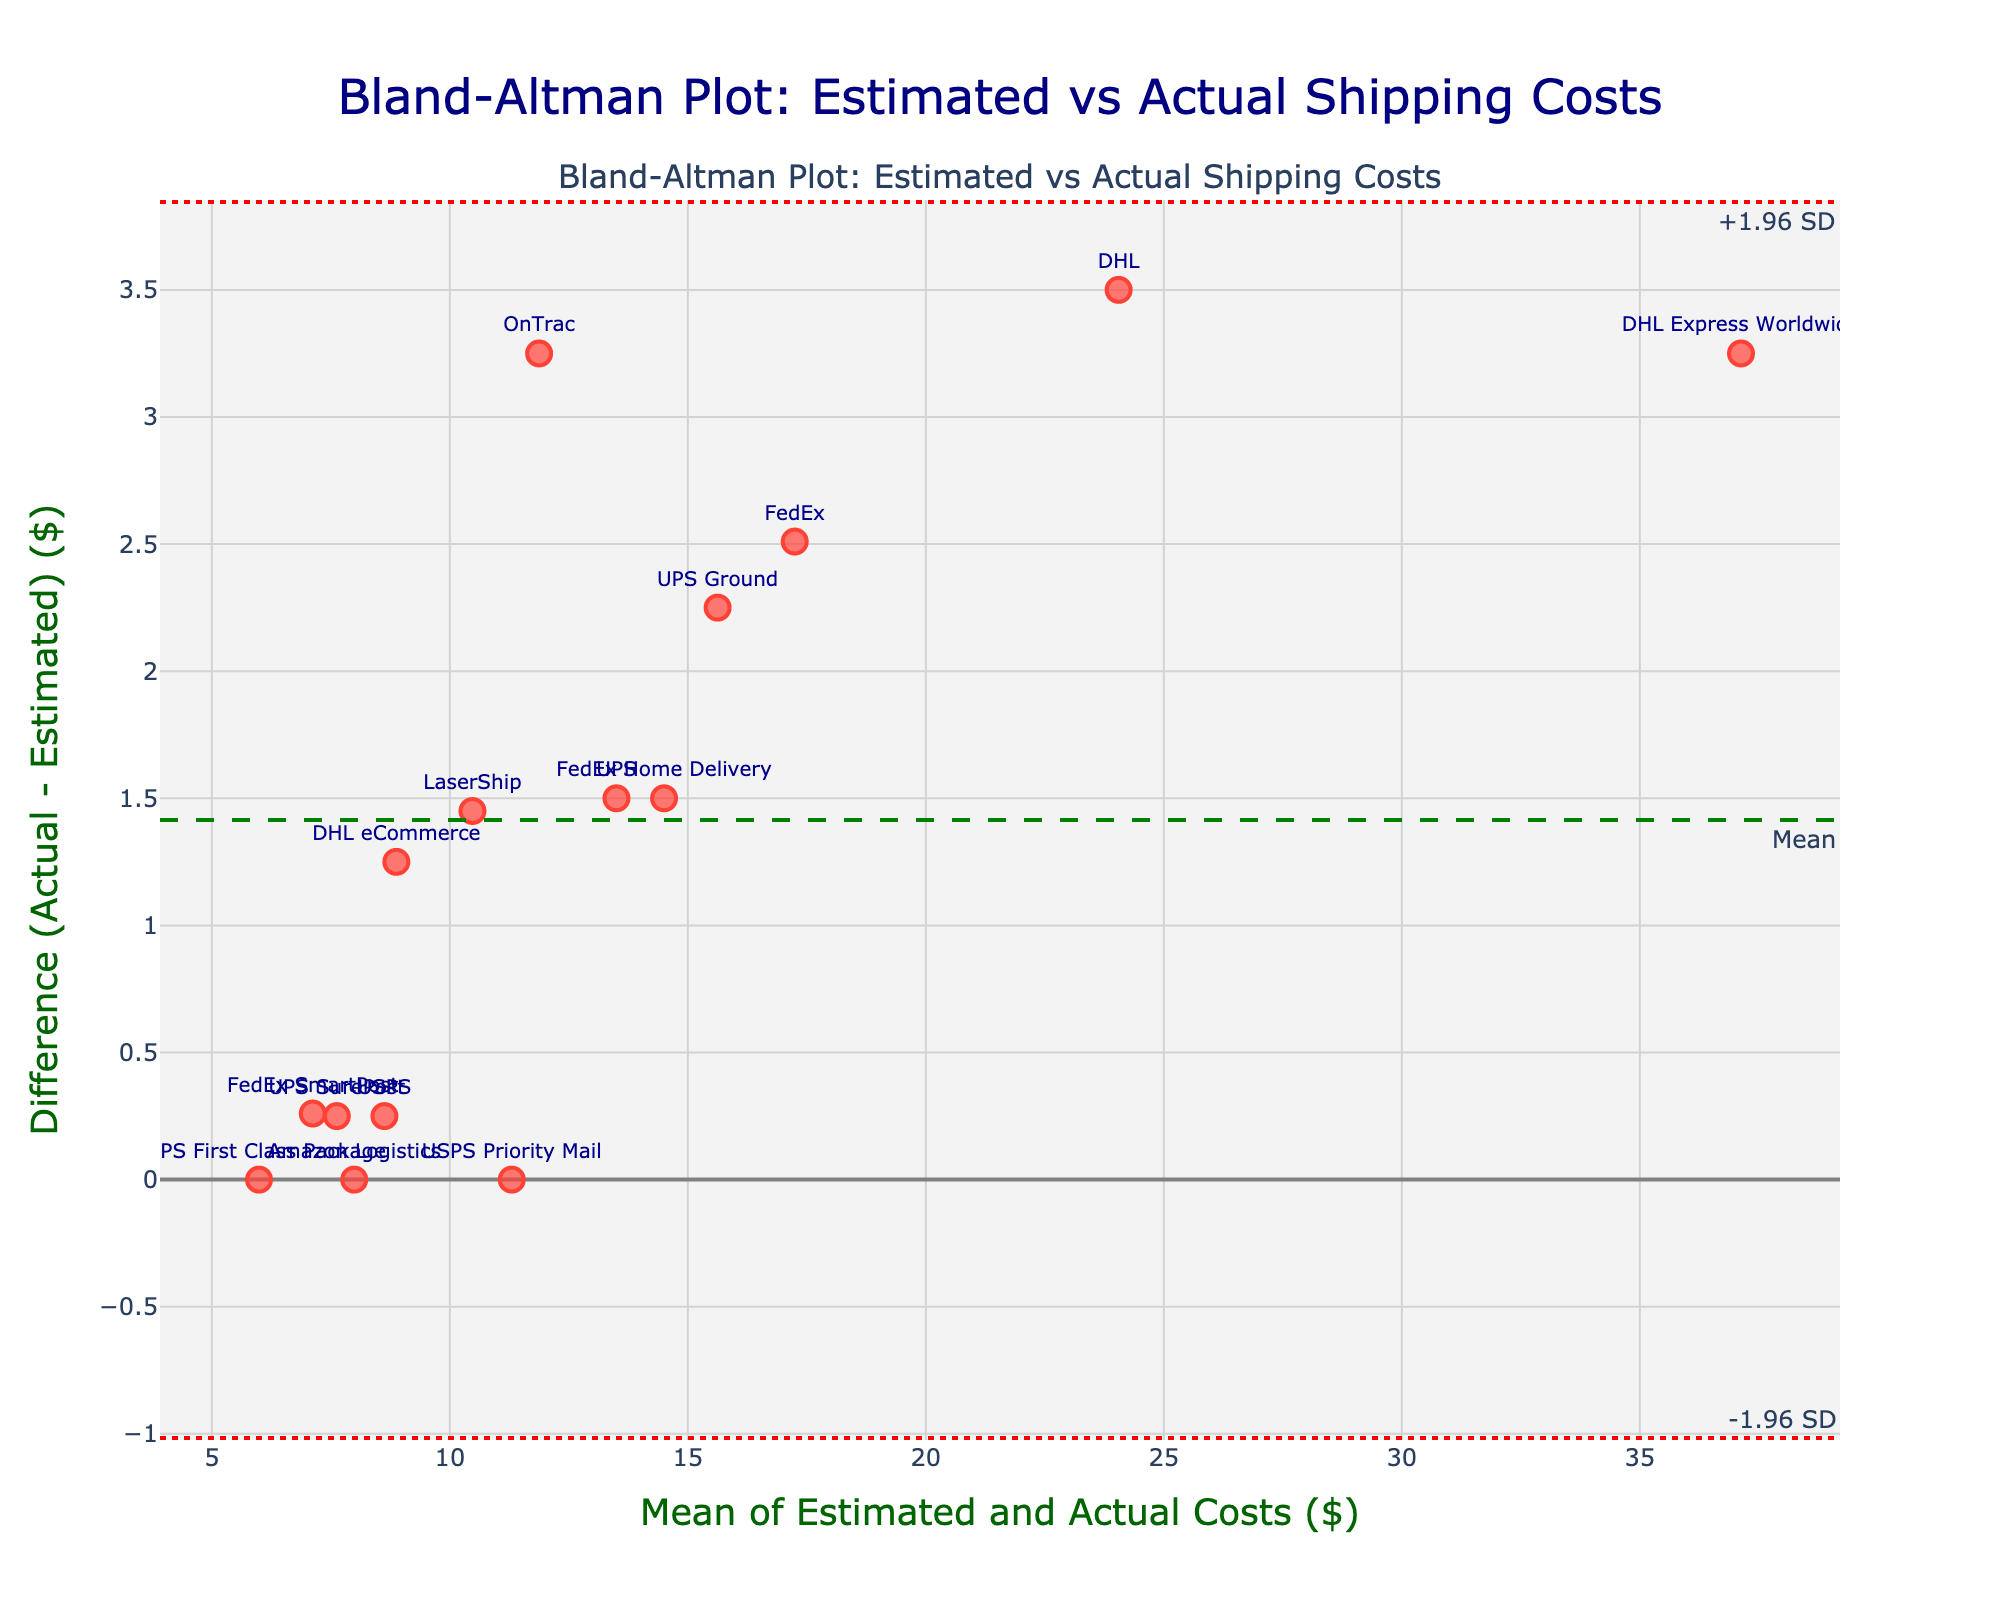Which carrier has the smallest difference between estimated and actual shipping costs? By observing the plot, you can see that `Amazon Logistics` and `USPS First Class Package` have zero difference between estimated and actual costs as their markers sit on the y-axis at zero difference.
Answer: Amazon Logistics, USPS First Class Package Which carrier has the largest positive difference between estimated and actual shipping costs? By examining the points farthest above the zero line on the y-axis, `DHL Express Worldwide` has the largest positive difference because its marker is the highest above the zero difference line.
Answer: DHL Express Worldwide What do the green, dashed and red, dotted lines represent? The green dashed line represents the mean difference between estimated and actual shipping costs. The red dotted lines denote the limits of agreement, which are ±1.96 standard deviations from the mean difference.
Answer: Mean difference, ±1.96 SD What is the mean of the estimated and actual shipping costs for `FedEx Home Delivery`? The mean of the estimated and actual values is calculated by taking the average of these two values. For `FedEx Home Delivery`, (13.75 + 15.25) / 2 = 14.50.
Answer: 14.50 What's the difference between the estimated and actual costs for `UPS Ground`? The difference is determined by subtracting the estimated cost from the actual cost. For `UPS Ground`, 16.75 - 14.50 = 2.25.
Answer: 2.25 Are any carriers' differences outside the limits of agreement? To determine if any points fall outside the limits of agreement, you need to observe if any markers lie above the upper red dotted line or below the lower red dotted line. In this plot, none of the carriers' differences appear to lie outside these bounds.
Answer: No Which carriers have exactly the same estimated and actual shipping costs? Markers that lie directly on the zero difference line represent carriers with no difference between estimated and actual costs. There are markers for `Amazon Logistics` and `USPS First Class Package` on this line.
Answer: Amazon Logistics, USPS First Class Package Which carrier has the highest mean of estimated and actual shipping costs? The marker farthest to the right on the x-axis represents the carrier with the highest mean of estimated and actual costs. This is `DHL Express Worldwide` with a mean of (35.50 + 38.75) / 2 = 37.13.
Answer: DHL Express Worldwide How many carriers have an actual cost higher than the estimated cost? Carriers with an actual cost higher than estimated will have markers above the zero difference line. By counting these markers, we determine there are 10 such carriers.
Answer: 10 